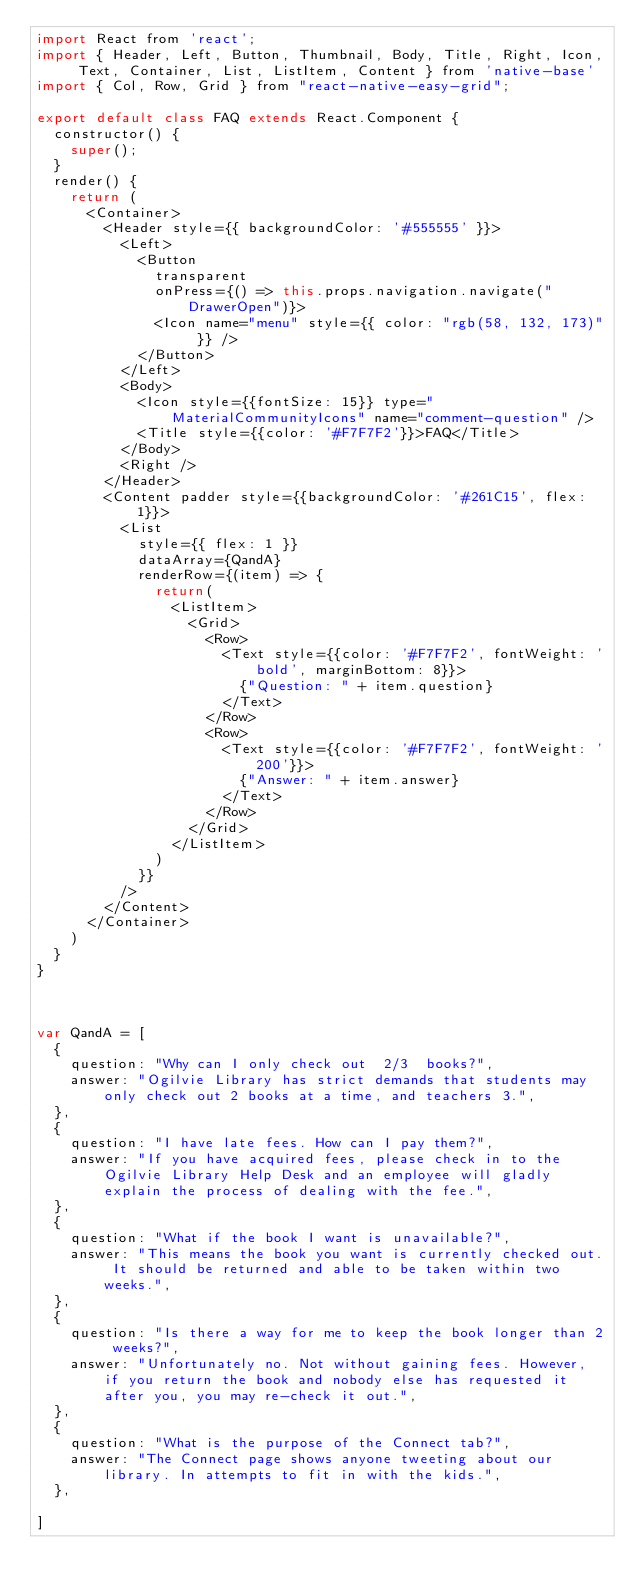<code> <loc_0><loc_0><loc_500><loc_500><_JavaScript_>import React from 'react';
import { Header, Left, Button, Thumbnail, Body, Title, Right, Icon, Text, Container, List, ListItem, Content } from 'native-base'
import { Col, Row, Grid } from "react-native-easy-grid";

export default class FAQ extends React.Component {
  constructor() {
    super();
  }
  render() {
    return (
      <Container>
        <Header style={{ backgroundColor: '#555555' }}>
          <Left>
            <Button
              transparent
              onPress={() => this.props.navigation.navigate("DrawerOpen")}>
              <Icon name="menu" style={{ color: "rgb(58, 132, 173)" }} />
            </Button>
          </Left>
          <Body>
            <Icon style={{fontSize: 15}} type="MaterialCommunityIcons" name="comment-question" />
            <Title style={{color: '#F7F7F2'}}>FAQ</Title>
          </Body>
          <Right />
        </Header>
        <Content padder style={{backgroundColor: '#261C15', flex: 1}}>
          <List
            style={{ flex: 1 }}
            dataArray={QandA}
            renderRow={(item) => {
              return(
                <ListItem>
                  <Grid>
                    <Row>
                      <Text style={{color: '#F7F7F2', fontWeight: 'bold', marginBottom: 8}}>
                        {"Question: " + item.question}
                      </Text>
                    </Row>
                    <Row>
                      <Text style={{color: '#F7F7F2', fontWeight: '200'}}>
                        {"Answer: " + item.answer}
                      </Text>
                    </Row>
                  </Grid>
                </ListItem>
              )
            }}
          />
        </Content>
      </Container>
    )
  }
}



var QandA = [
  {
    question: "Why can I only check out  2/3  books?",
    answer: "Ogilvie Library has strict demands that students may only check out 2 books at a time, and teachers 3.",
  },
  {
    question: "I have late fees. How can I pay them?",
    answer: "If you have acquired fees, please check in to the Ogilvie Library Help Desk and an employee will gladly explain the process of dealing with the fee.",
  },
  {
    question: "What if the book I want is unavailable?",
    answer: "This means the book you want is currently checked out. It should be returned and able to be taken within two weeks.",
  },
  {
    question: "Is there a way for me to keep the book longer than 2 weeks?",
    answer: "Unfortunately no. Not without gaining fees. However, if you return the book and nobody else has requested it after you, you may re-check it out.",
  },
  {
    question: "What is the purpose of the Connect tab?",
    answer: "The Connect page shows anyone tweeting about our library. In attempts to fit in with the kids.",
  },

]
</code> 